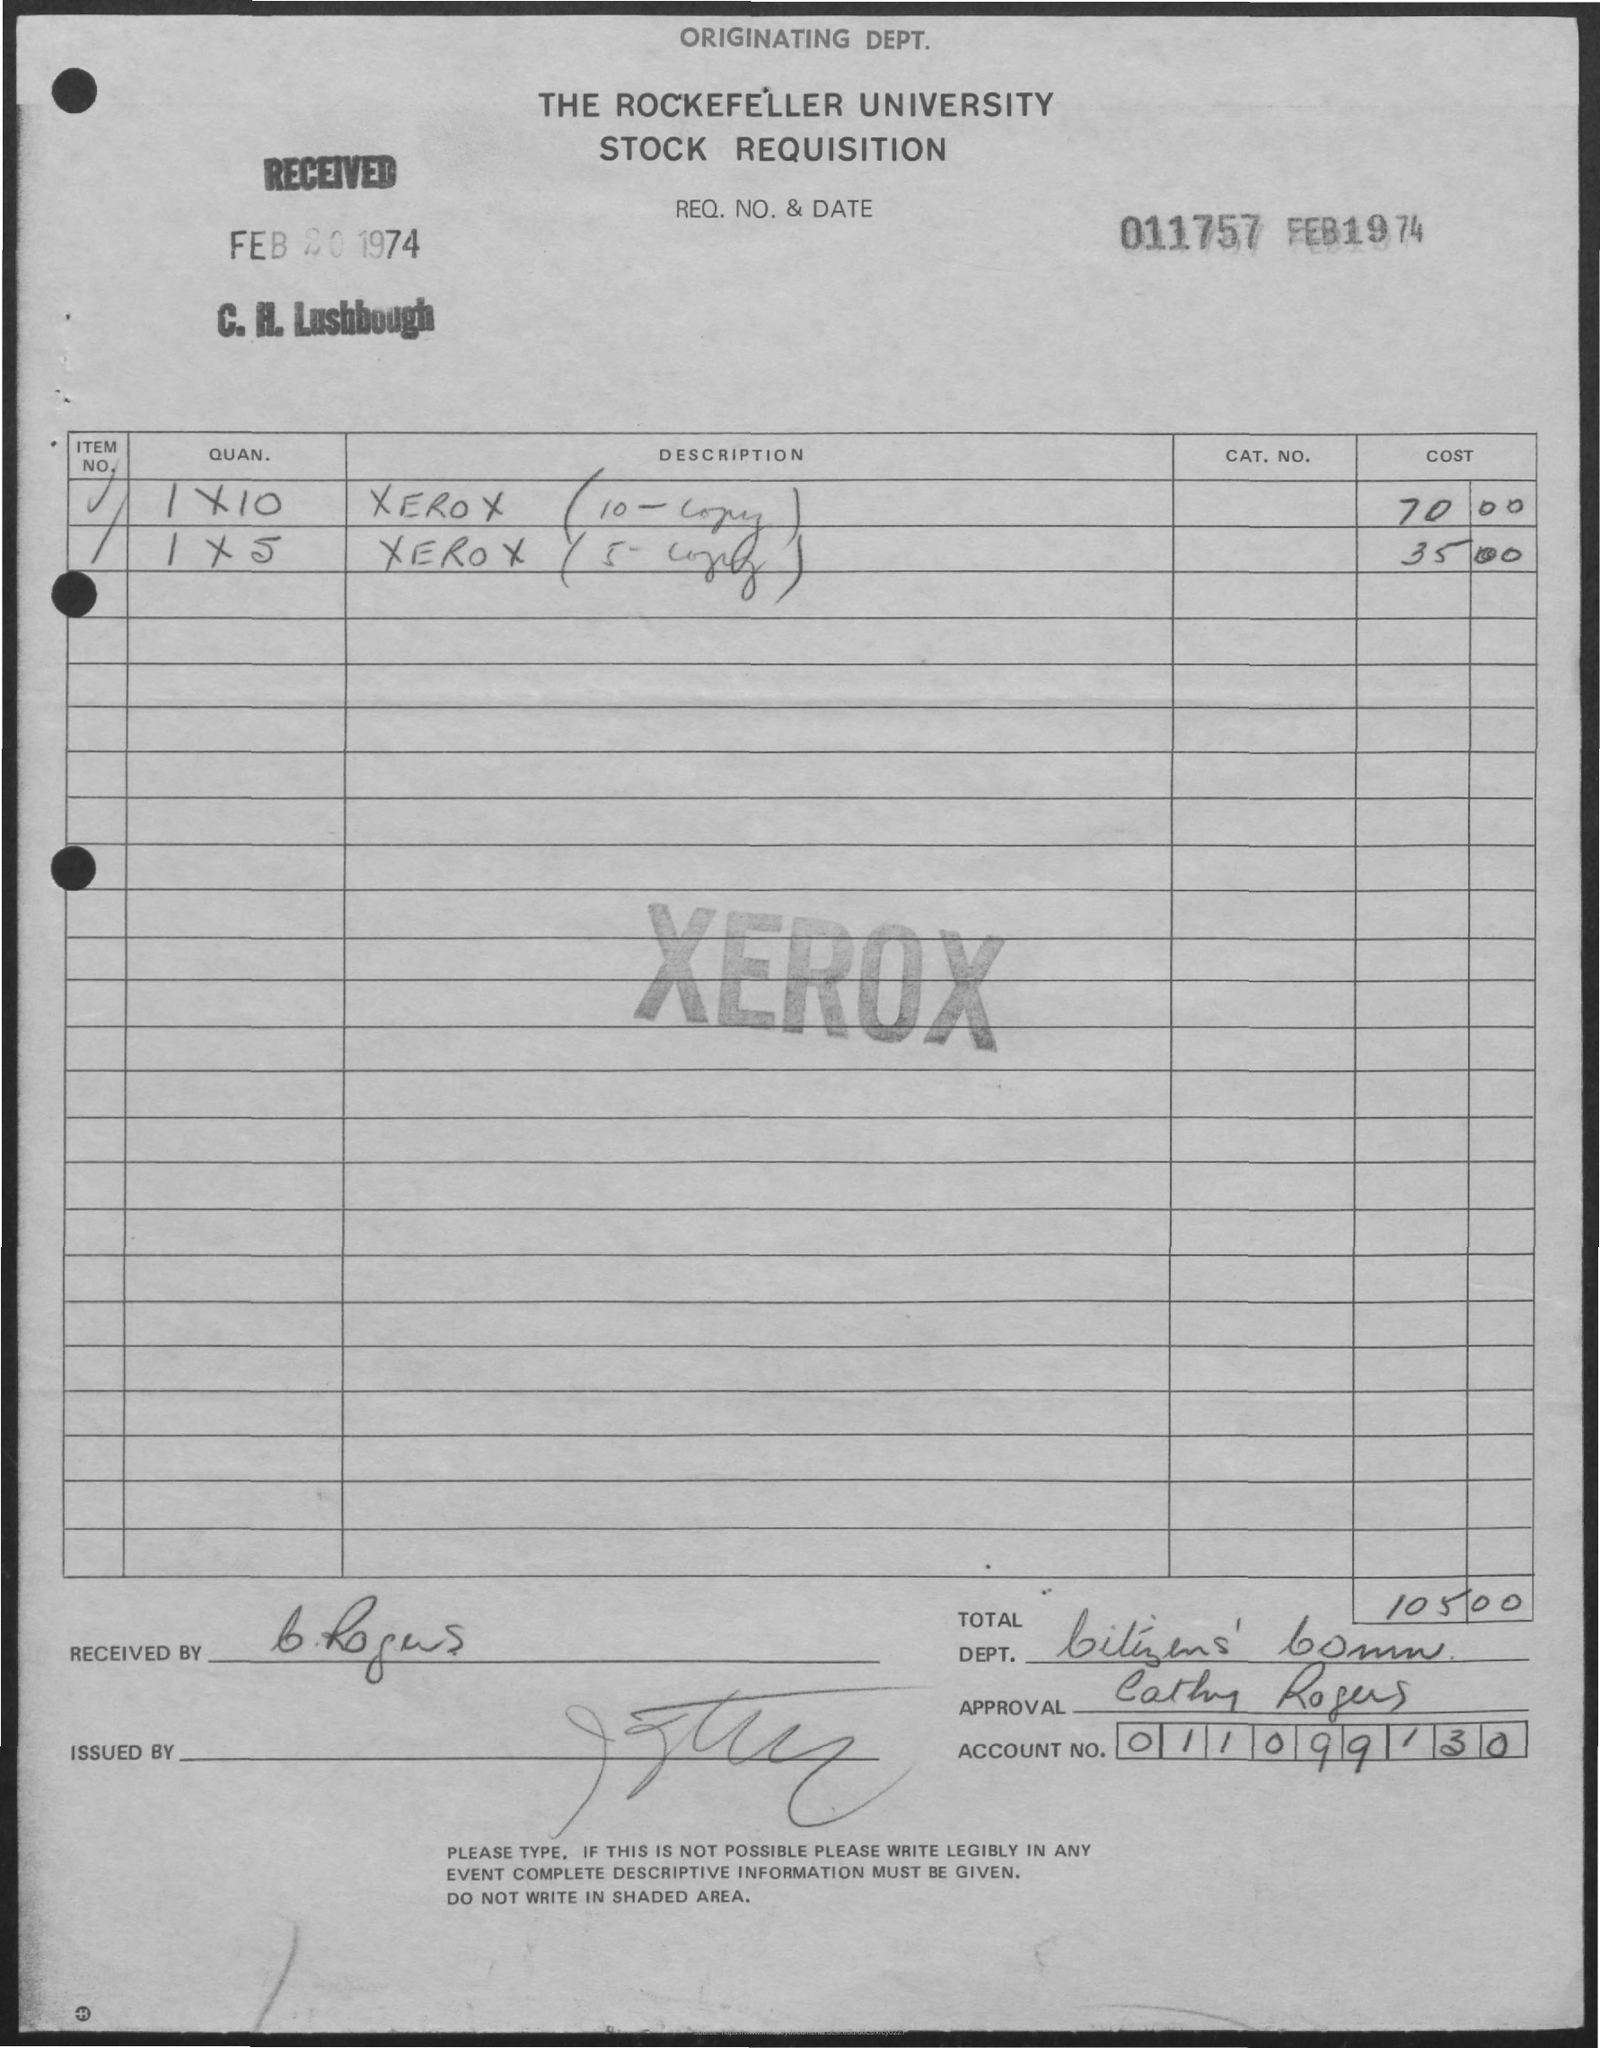What is the name of the university
Provide a short and direct response. The Rockefeller university. What is the date of received ?
Offer a terse response. Feb 20 1974. What is the month and year mentioned
Your answer should be very brief. FEB 1974. What is the cost of xerox (10-copy )
Your answer should be very brief. 70.00. What is the cost of xerox (5- copy)
Your answer should be very brief. 35.00. What is the account no ?
Provide a succinct answer. 011099130. What is the name mentioned in the approval
Make the answer very short. CATHY ROGERS. 